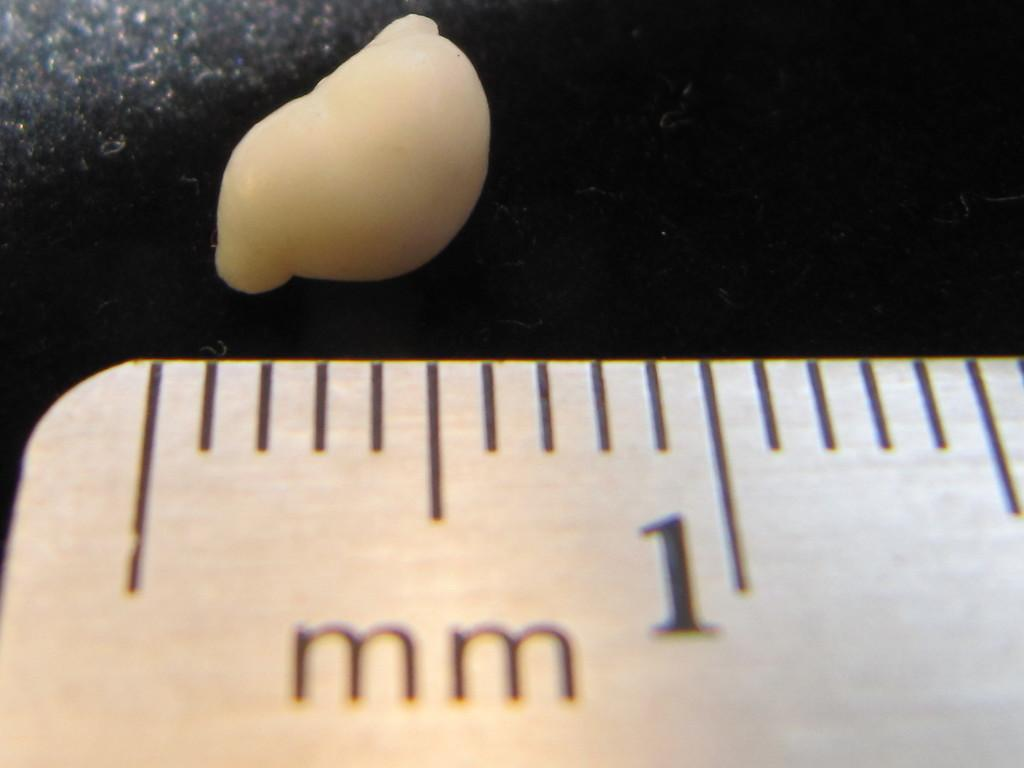<image>
Render a clear and concise summary of the photo. the number 1 is on the white ruler 